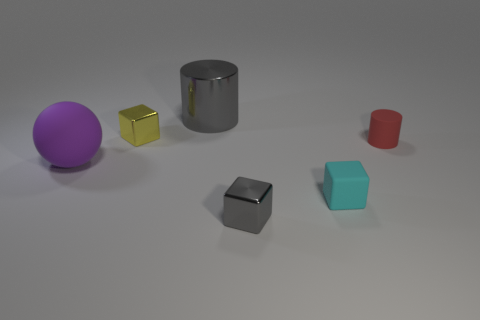Looking at the composition, could this be an image used for a specific purpose? This image, featuring a variety of geometric shapes with distinct colors and textures on a neutral background, has the hallmarks of being designed for educational purposes or graphical rendering tests. Its simplicity and clarity make it suitable for demonstrating object properties in educational materials or for calibration and testing in computer graphics work. 